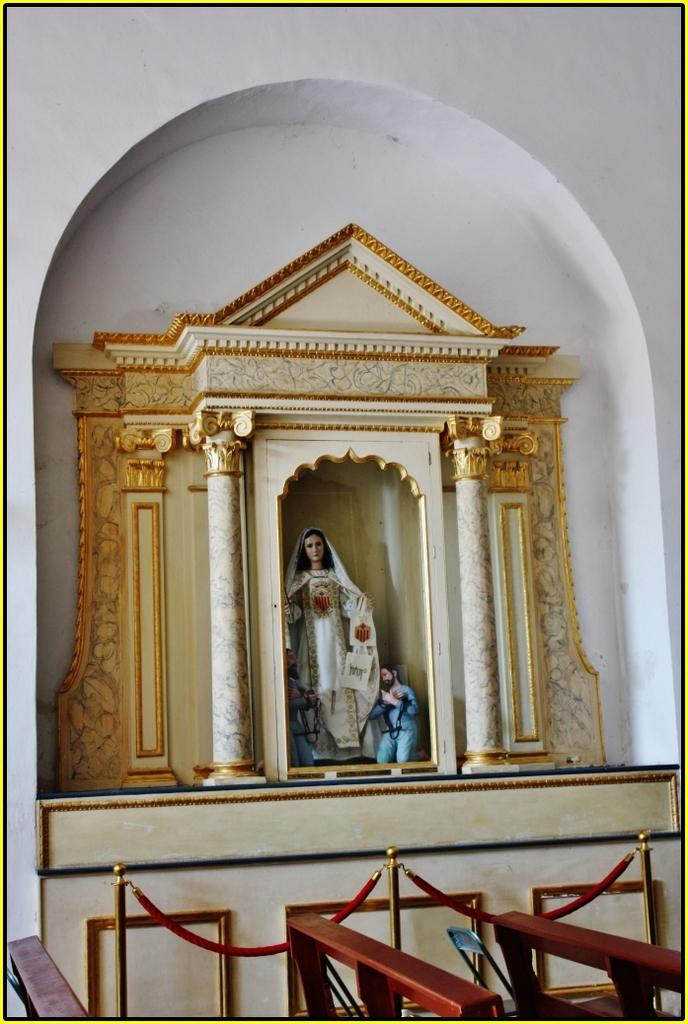What is the main subject of the image? There is a statue in the image. What is the statue wearing? The statue is wearing a white dress. What other architectural features can be seen in the image? There are two pillars in the image. What color is the background wall? The background wall is white. What type of news can be heard coming from the cave in the image? There is no cave present in the image, so it's not possible to determine what, if any, news might be heard. 